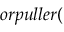<formula> <loc_0><loc_0><loc_500><loc_500>o r p u l l e r (</formula> 